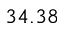Convert formula to latex. <formula><loc_0><loc_0><loc_500><loc_500>3 4 . 3 8</formula> 